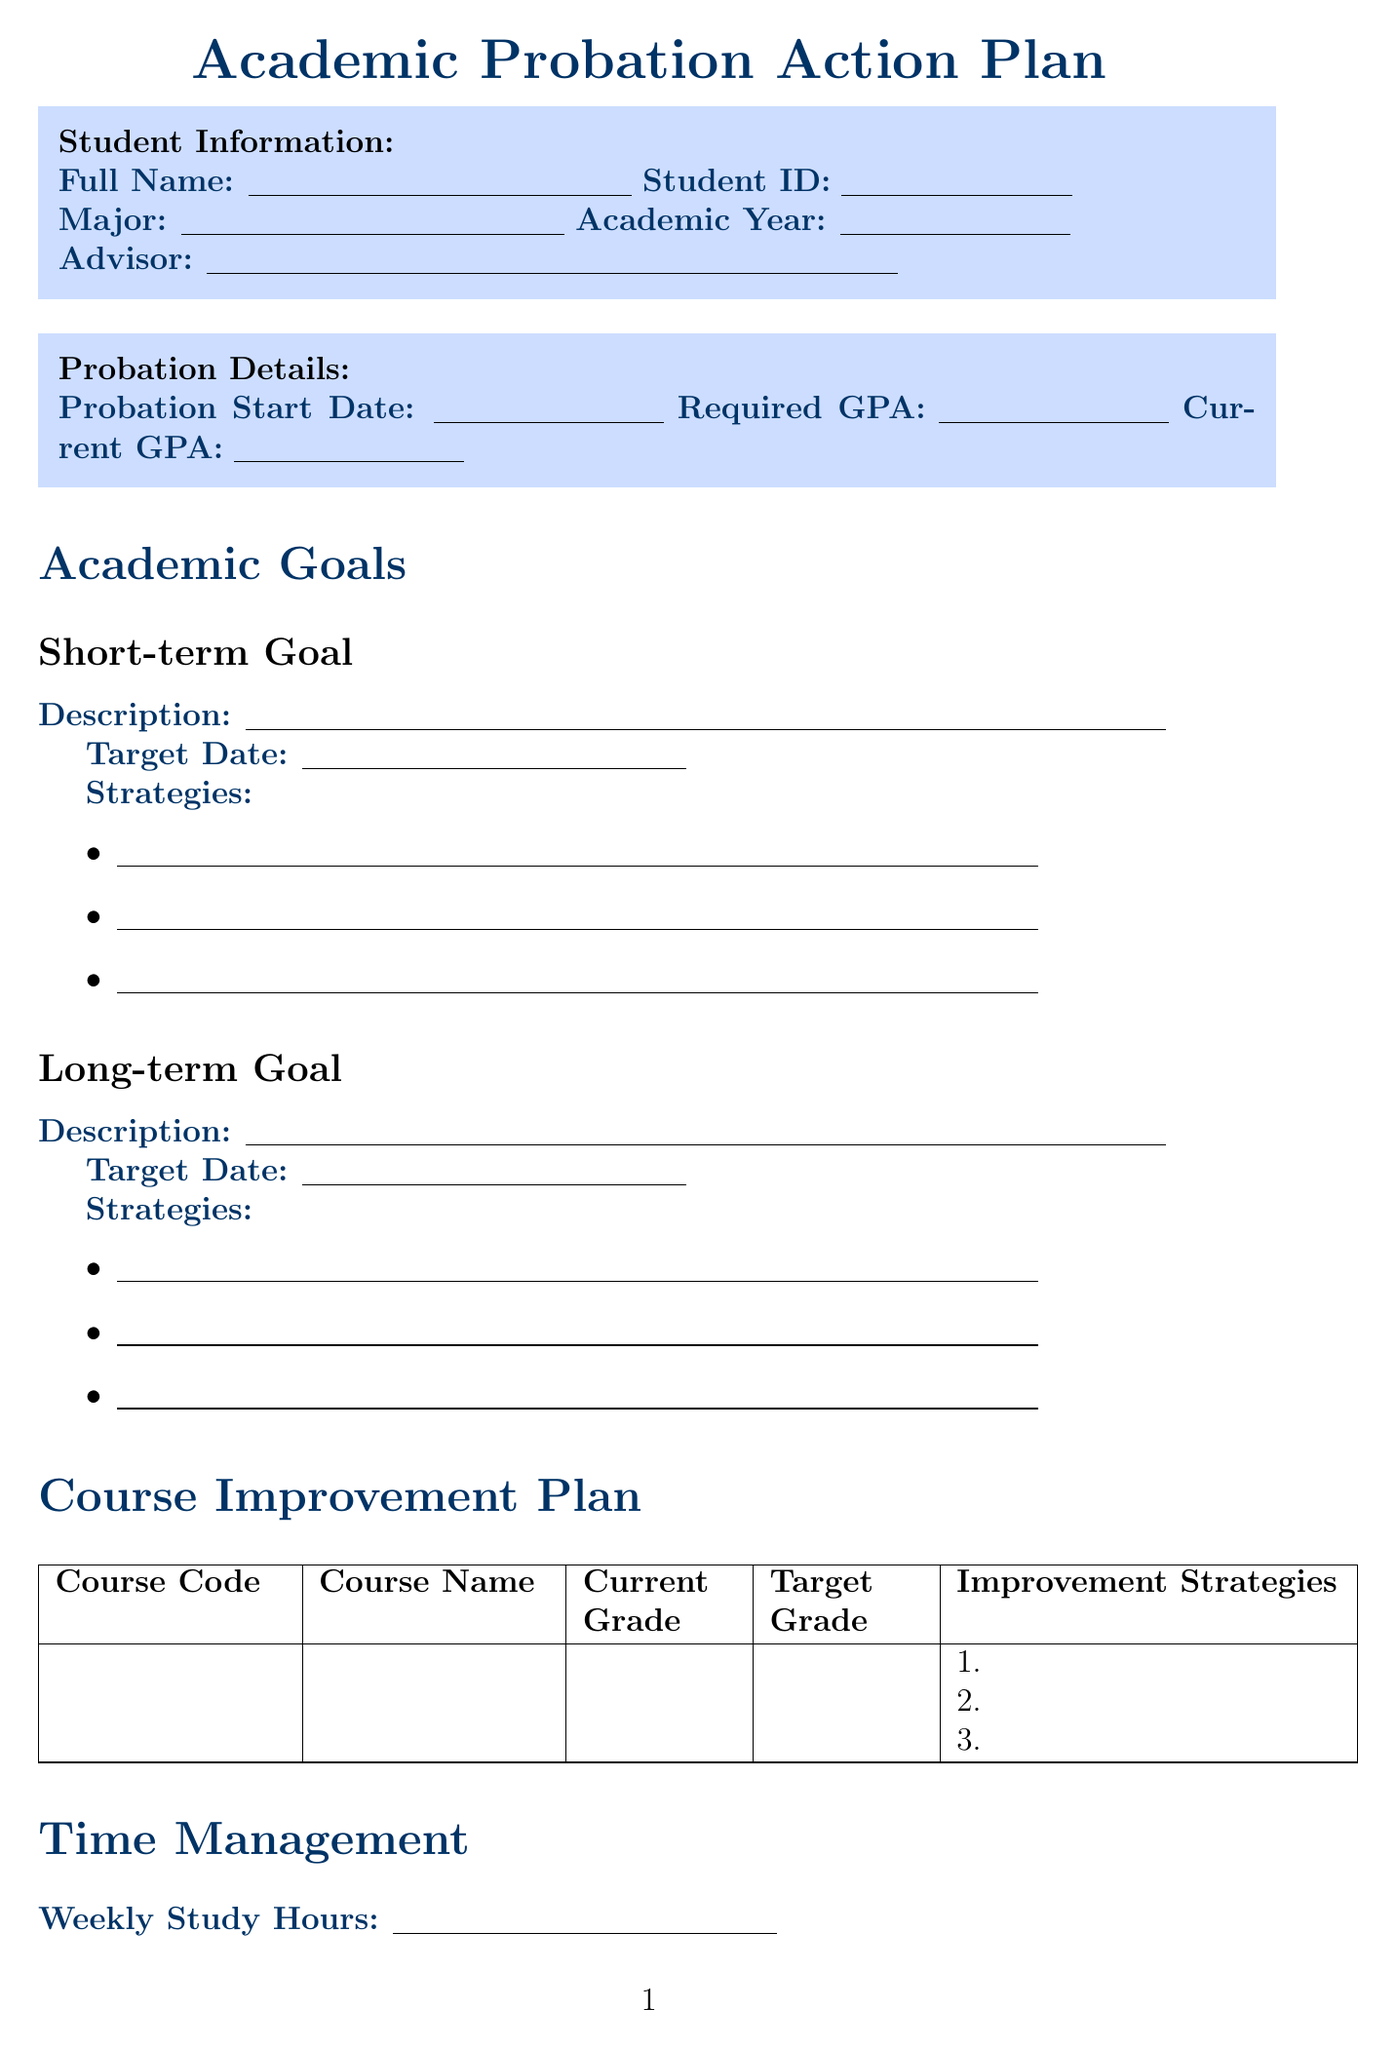what is the title of the form? The title of the form is stated clearly at the beginning of the document.
Answer: Academic Probation Action Plan how many courses are listed for improvement? The document has a section specifically for course improvement, which allows for a specific number of entries.
Answer: 1 what is the name of a campus resource listed? The document lists several campus resources in the Campus Resources Utilization section.
Answer: Writing Center how often are bi-weekly check-ins scheduled? The document indicates that bi-weekly check-ins are a part of the Progress Tracking section.
Answer: Every two weeks what is the date format used for check-ins? The date format for the check-ins is implied from the structure of the table in the document.
Answer: Date format is MM/DD/YYYY 